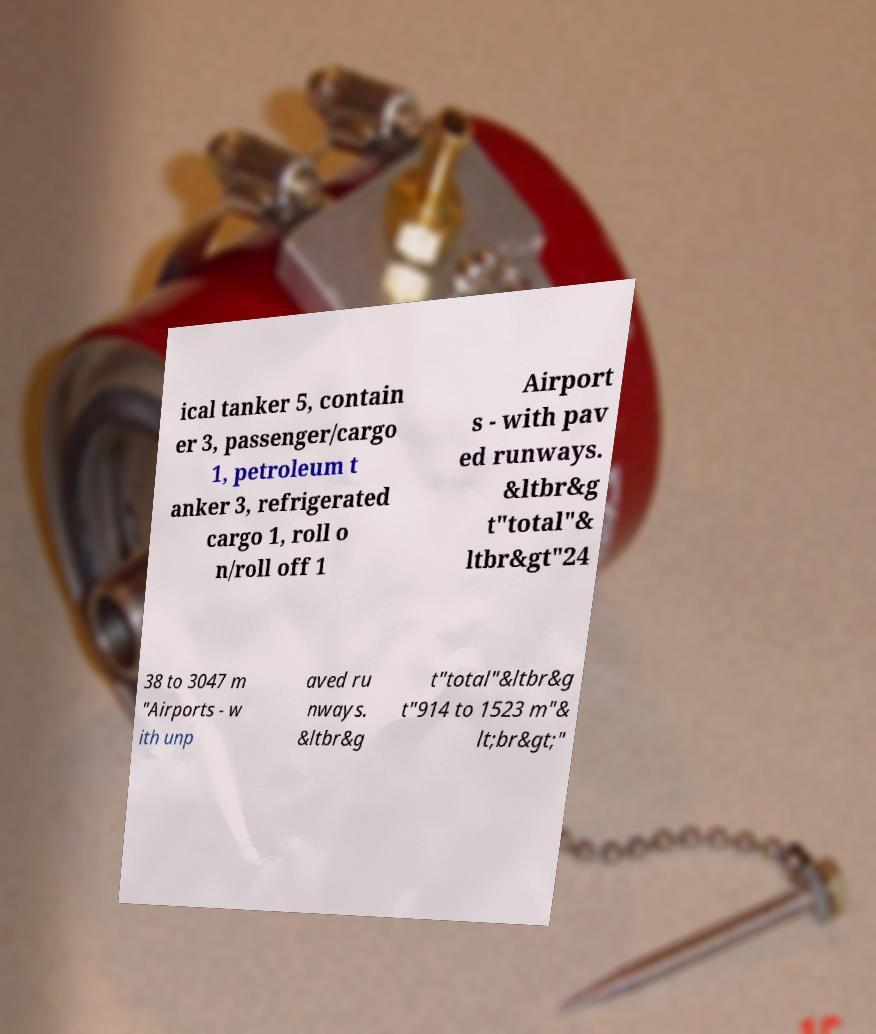There's text embedded in this image that I need extracted. Can you transcribe it verbatim? ical tanker 5, contain er 3, passenger/cargo 1, petroleum t anker 3, refrigerated cargo 1, roll o n/roll off 1 Airport s - with pav ed runways. &ltbr&g t"total"& ltbr&gt"24 38 to 3047 m "Airports - w ith unp aved ru nways. &ltbr&g t"total"&ltbr&g t"914 to 1523 m"& lt;br&gt;" 